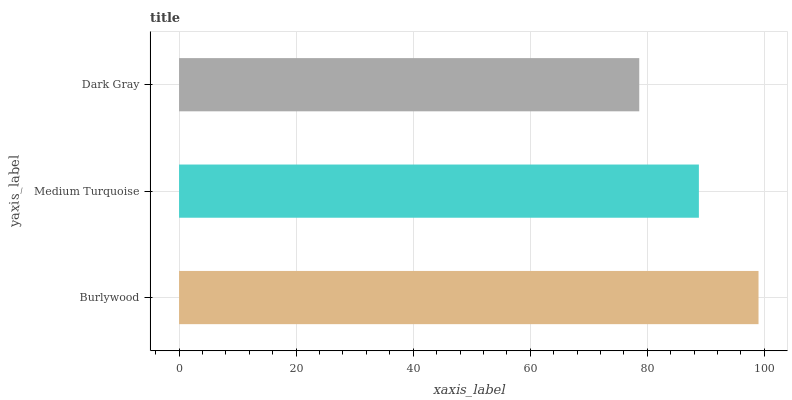Is Dark Gray the minimum?
Answer yes or no. Yes. Is Burlywood the maximum?
Answer yes or no. Yes. Is Medium Turquoise the minimum?
Answer yes or no. No. Is Medium Turquoise the maximum?
Answer yes or no. No. Is Burlywood greater than Medium Turquoise?
Answer yes or no. Yes. Is Medium Turquoise less than Burlywood?
Answer yes or no. Yes. Is Medium Turquoise greater than Burlywood?
Answer yes or no. No. Is Burlywood less than Medium Turquoise?
Answer yes or no. No. Is Medium Turquoise the high median?
Answer yes or no. Yes. Is Medium Turquoise the low median?
Answer yes or no. Yes. Is Dark Gray the high median?
Answer yes or no. No. Is Burlywood the low median?
Answer yes or no. No. 